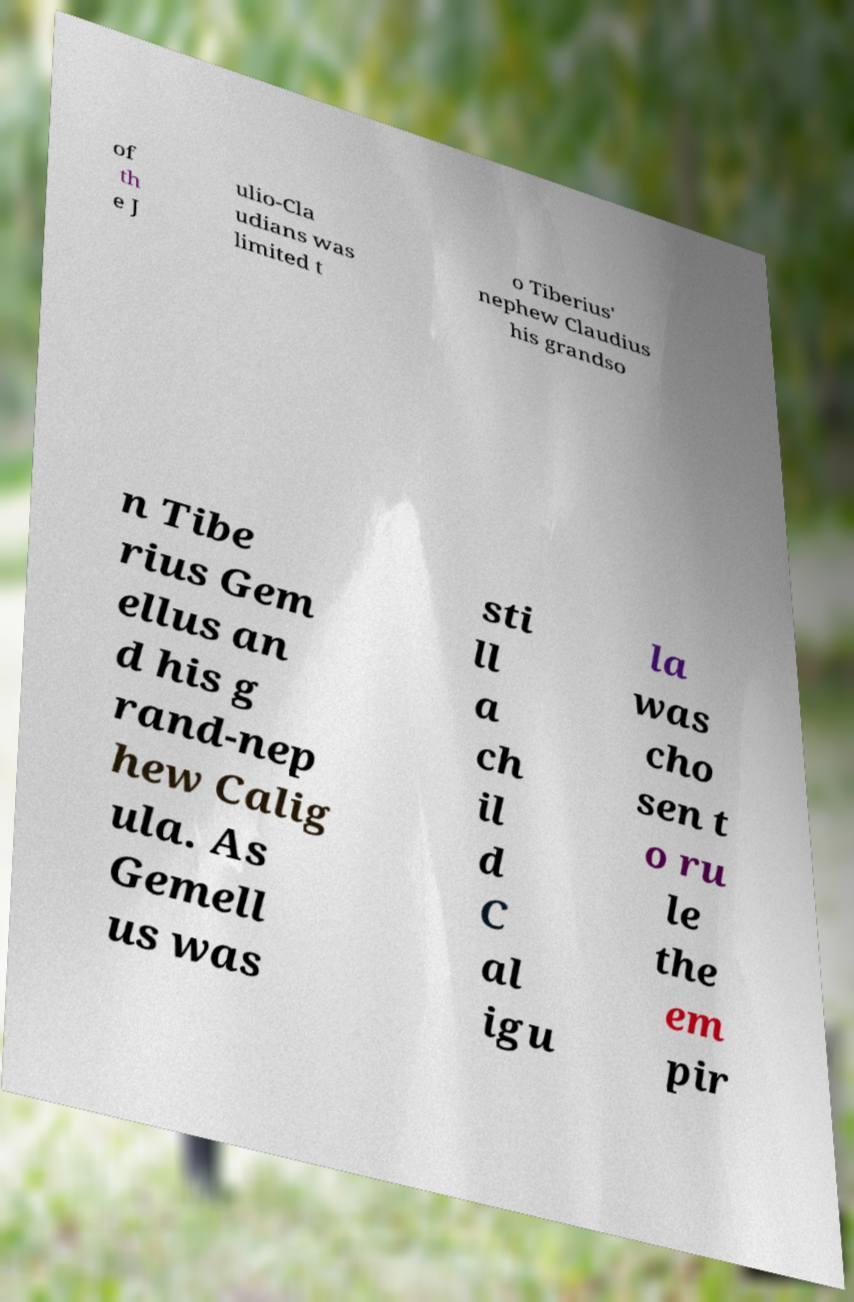I need the written content from this picture converted into text. Can you do that? of th e J ulio-Cla udians was limited t o Tiberius' nephew Claudius his grandso n Tibe rius Gem ellus an d his g rand-nep hew Calig ula. As Gemell us was sti ll a ch il d C al igu la was cho sen t o ru le the em pir 